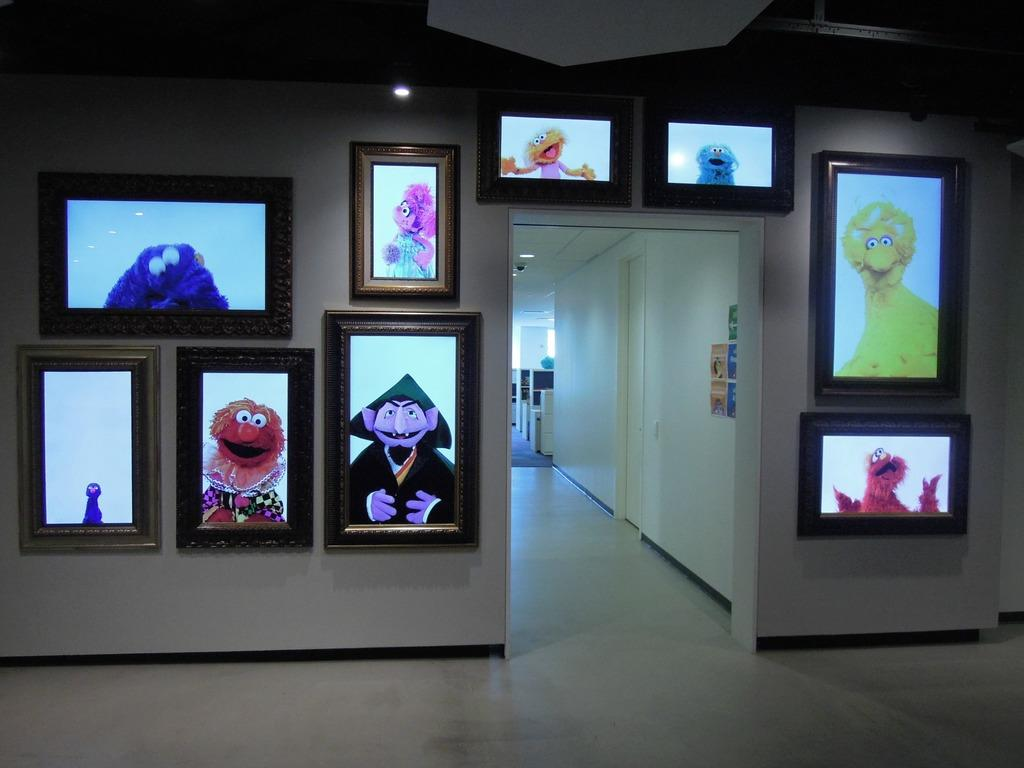What is attached to the wall in the image? There are frames and papers pasted on a wall in the image. What is the purpose of the door in the image? The door in the image provides access to another room or area. What type of lighting is present in the image? There are ceiling lights in the image. Where are the ceiling lights attached? The ceiling lights are attached to the roof in the image. How many babies are running around with a basket in the image? There are no babies or baskets present in the image. What type of basket is hanging from the ceiling lights? There is no basket present in the image, and the ceiling lights are attached to the roof, not hanging from anything. 